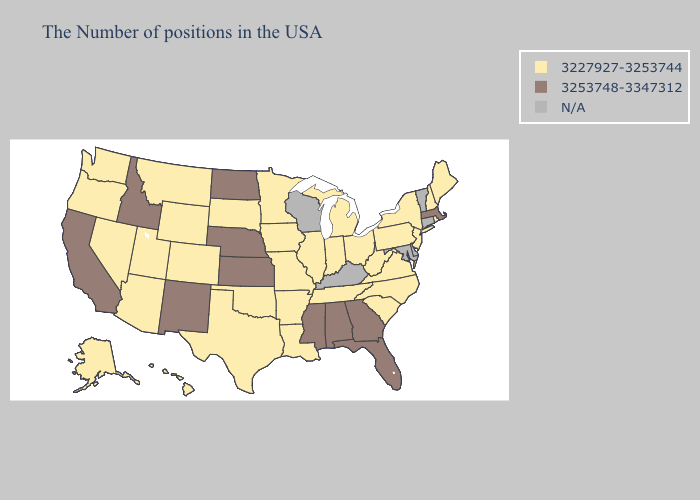What is the highest value in states that border Arizona?
Quick response, please. 3253748-3347312. Does Indiana have the highest value in the USA?
Be succinct. No. What is the lowest value in the MidWest?
Give a very brief answer. 3227927-3253744. Among the states that border Nebraska , which have the lowest value?
Keep it brief. Missouri, Iowa, South Dakota, Wyoming, Colorado. Among the states that border Louisiana , which have the highest value?
Keep it brief. Mississippi. Name the states that have a value in the range N/A?
Write a very short answer. Vermont, Connecticut, Delaware, Maryland, Kentucky, Wisconsin. What is the value of Hawaii?
Write a very short answer. 3227927-3253744. Which states have the lowest value in the MidWest?
Write a very short answer. Ohio, Michigan, Indiana, Illinois, Missouri, Minnesota, Iowa, South Dakota. Is the legend a continuous bar?
Quick response, please. No. Name the states that have a value in the range N/A?
Give a very brief answer. Vermont, Connecticut, Delaware, Maryland, Kentucky, Wisconsin. Which states have the lowest value in the Northeast?
Answer briefly. Maine, Rhode Island, New Hampshire, New York, New Jersey, Pennsylvania. Does the first symbol in the legend represent the smallest category?
Give a very brief answer. Yes. What is the value of Arkansas?
Write a very short answer. 3227927-3253744. 